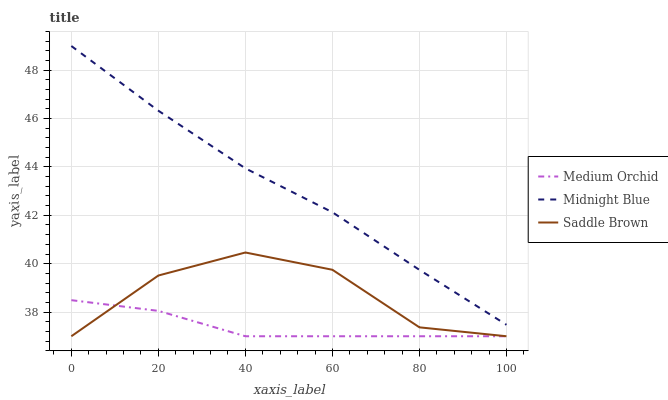Does Saddle Brown have the minimum area under the curve?
Answer yes or no. No. Does Saddle Brown have the maximum area under the curve?
Answer yes or no. No. Is Saddle Brown the smoothest?
Answer yes or no. No. Is Midnight Blue the roughest?
Answer yes or no. No. Does Midnight Blue have the lowest value?
Answer yes or no. No. Does Saddle Brown have the highest value?
Answer yes or no. No. Is Saddle Brown less than Midnight Blue?
Answer yes or no. Yes. Is Midnight Blue greater than Medium Orchid?
Answer yes or no. Yes. Does Saddle Brown intersect Midnight Blue?
Answer yes or no. No. 